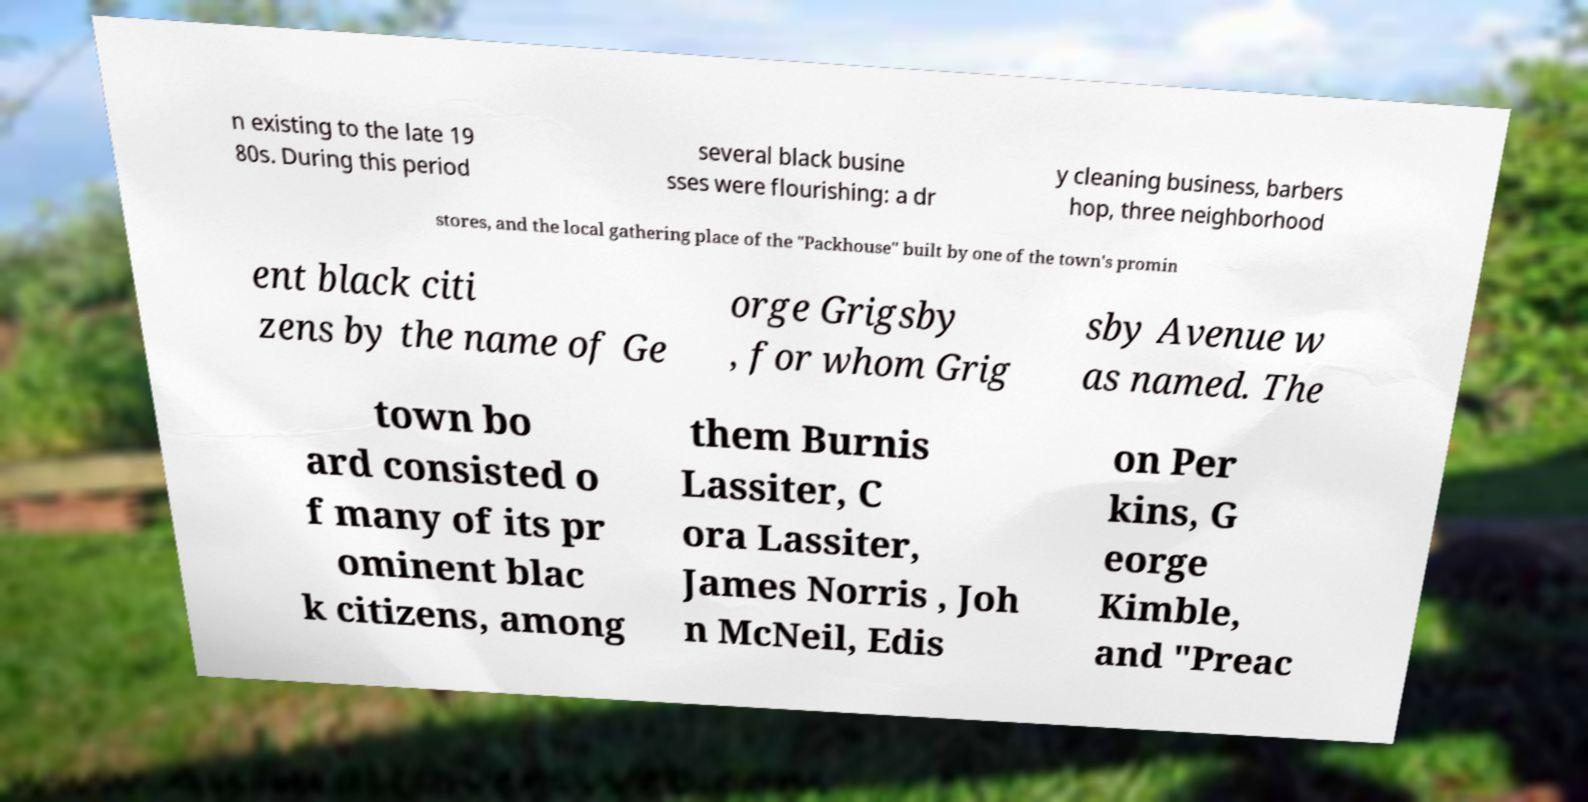Please identify and transcribe the text found in this image. n existing to the late 19 80s. During this period several black busine sses were flourishing: a dr y cleaning business, barbers hop, three neighborhood stores, and the local gathering place of the "Packhouse" built by one of the town's promin ent black citi zens by the name of Ge orge Grigsby , for whom Grig sby Avenue w as named. The town bo ard consisted o f many of its pr ominent blac k citizens, among them Burnis Lassiter, C ora Lassiter, James Norris , Joh n McNeil, Edis on Per kins, G eorge Kimble, and "Preac 